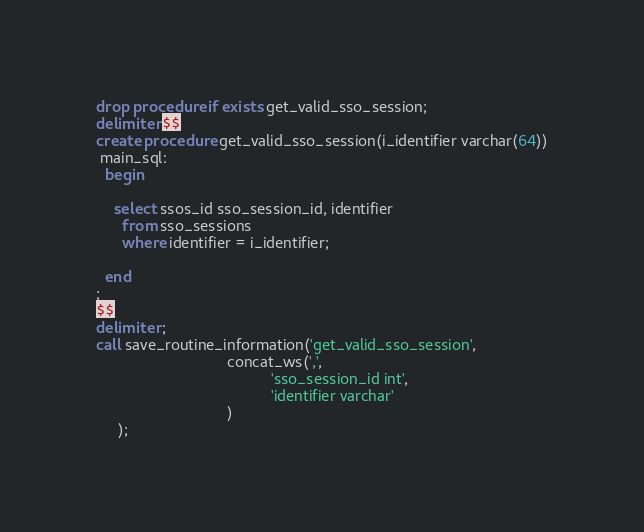Convert code to text. <code><loc_0><loc_0><loc_500><loc_500><_SQL_>drop procedure if exists get_valid_sso_session;
delimiter $$
create procedure get_valid_sso_session(i_identifier varchar(64))
 main_sql:
  begin

    select ssos_id sso_session_id, identifier
      from sso_sessions
      where identifier = i_identifier;
  
  end
;
$$
delimiter ;
call save_routine_information('get_valid_sso_session',
                              concat_ws(',',
                                        'sso_session_id int',
                                        'identifier varchar'
                              )
     );</code> 